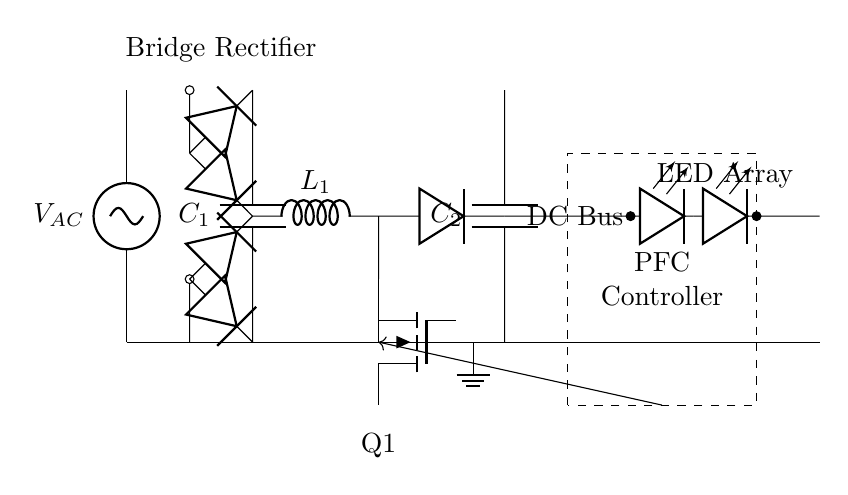What type of rectifier is used in this circuit? The circuit diagram shows a bridge rectifier, which consists of four diodes arranged in a bridge configuration to convert AC to DC.
Answer: Bridge rectifier What is the role of the capacitor labeled C1? The capacitor C1 is a smoothing capacitor, which serves to reduce ripple in the DC output from the rectifier, ensuring a more stable DC voltage supply.
Answer: Smoothing capacitor What component is represented by L1 in the circuit? L1 is an inductor, often used in power factor correction circuits to store energy and regulate current flow, especially in conjunction with a switching element like the transistor Q1.
Answer: Inductor How does the PFC controller interact with the circuit? The PFC controller regulates the voltage and current delivered to the LED array by controlling the operation of the switching element Q1, helping to improve the overall power factor of the circuit.
Answer: Regulates voltage and current What is the function of the LED array in this circuit? The LED array represents the load and serves as the output where the converted and regulated DC power is used for illumination, as LEDs require DC voltage for operation.
Answer: Illumination How does the arrangement of diodes in the bridge rectifier ensure proper operation? The bridge topology allows for current to flow through the load in either polarity of the input AC, ensuring that the output is always in the same direction regardless of the input's polarity.
Answer: Current flows in one direction 